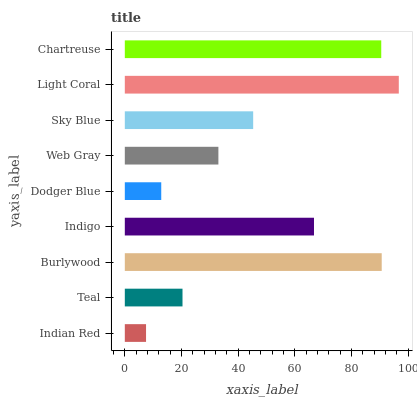Is Indian Red the minimum?
Answer yes or no. Yes. Is Light Coral the maximum?
Answer yes or no. Yes. Is Teal the minimum?
Answer yes or no. No. Is Teal the maximum?
Answer yes or no. No. Is Teal greater than Indian Red?
Answer yes or no. Yes. Is Indian Red less than Teal?
Answer yes or no. Yes. Is Indian Red greater than Teal?
Answer yes or no. No. Is Teal less than Indian Red?
Answer yes or no. No. Is Sky Blue the high median?
Answer yes or no. Yes. Is Sky Blue the low median?
Answer yes or no. Yes. Is Chartreuse the high median?
Answer yes or no. No. Is Burlywood the low median?
Answer yes or no. No. 